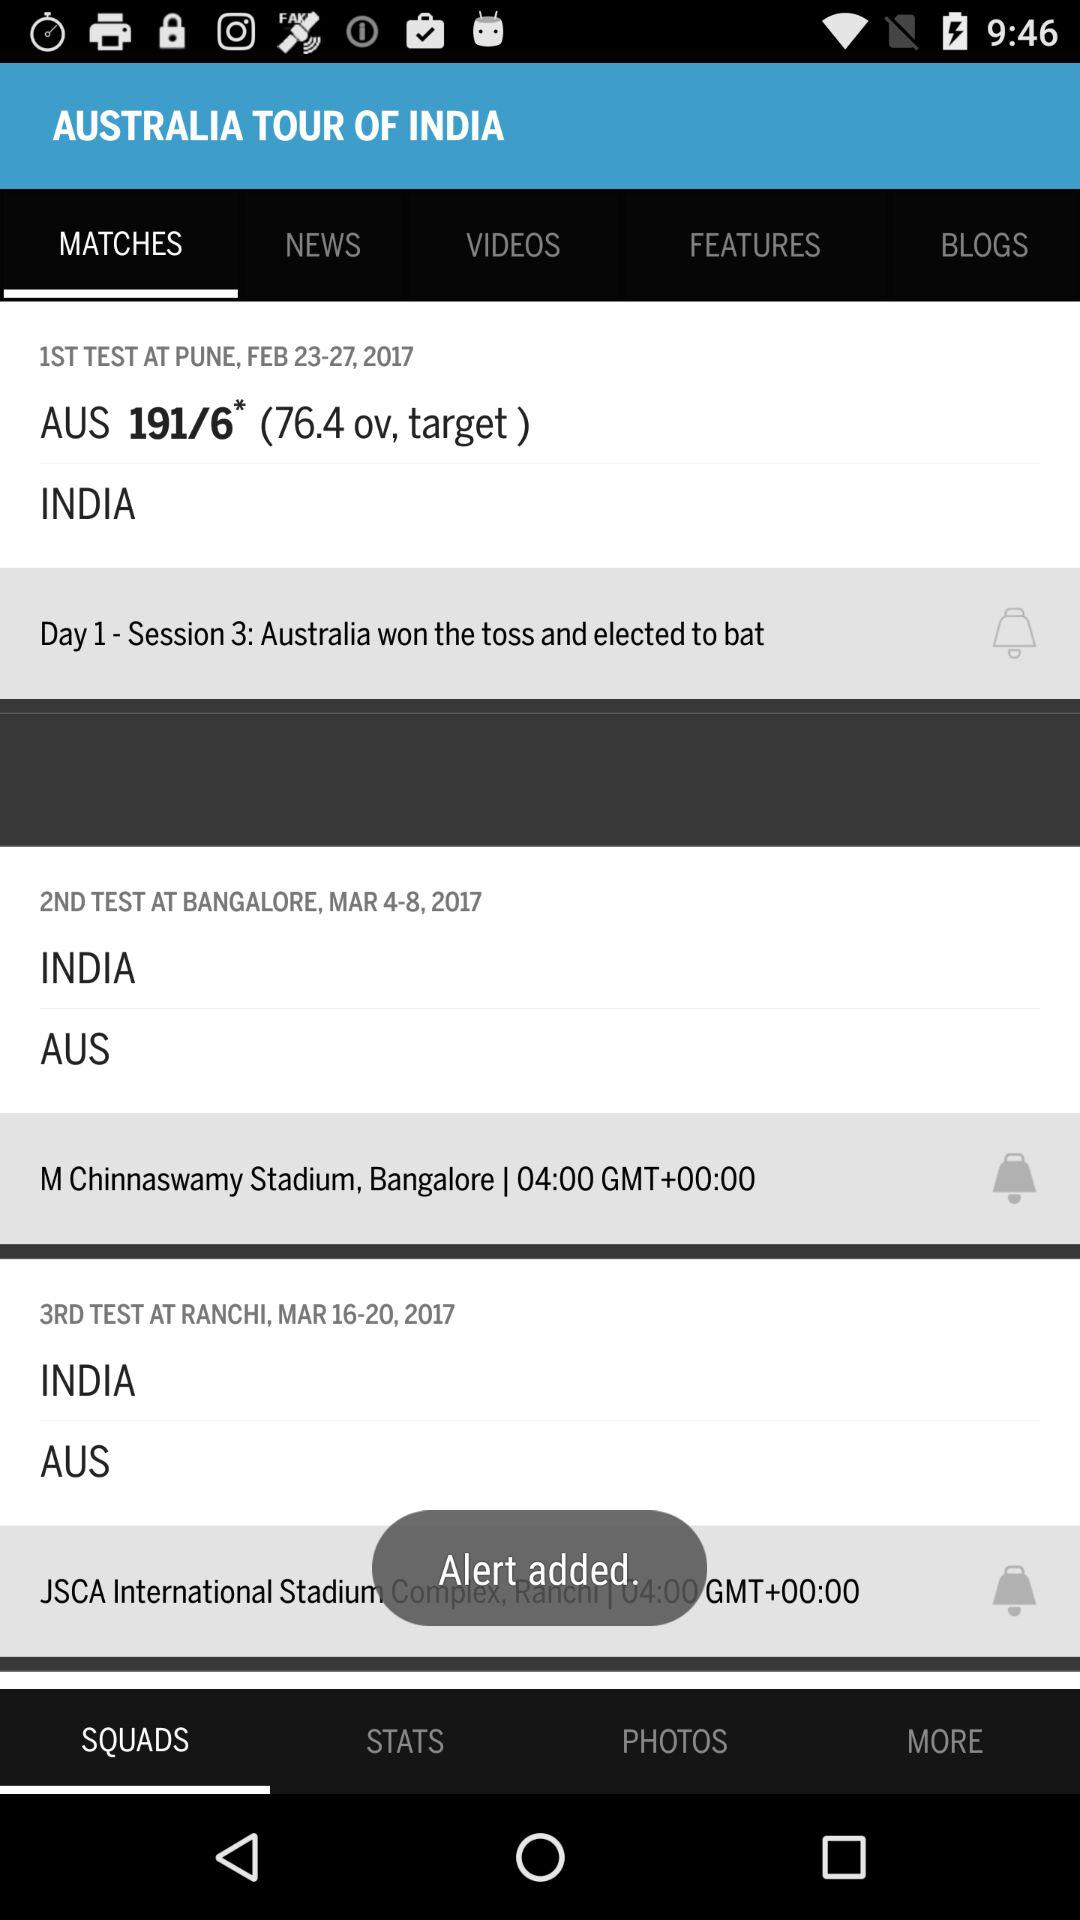How many matches are in the series?
Answer the question using a single word or phrase. 3 